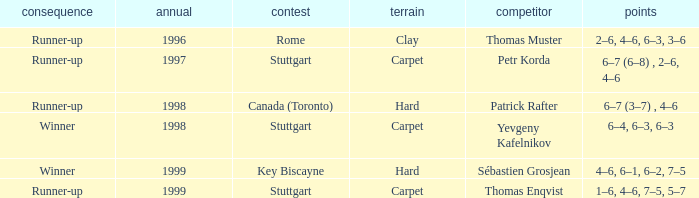How many years was the opponent petr korda? 1.0. 